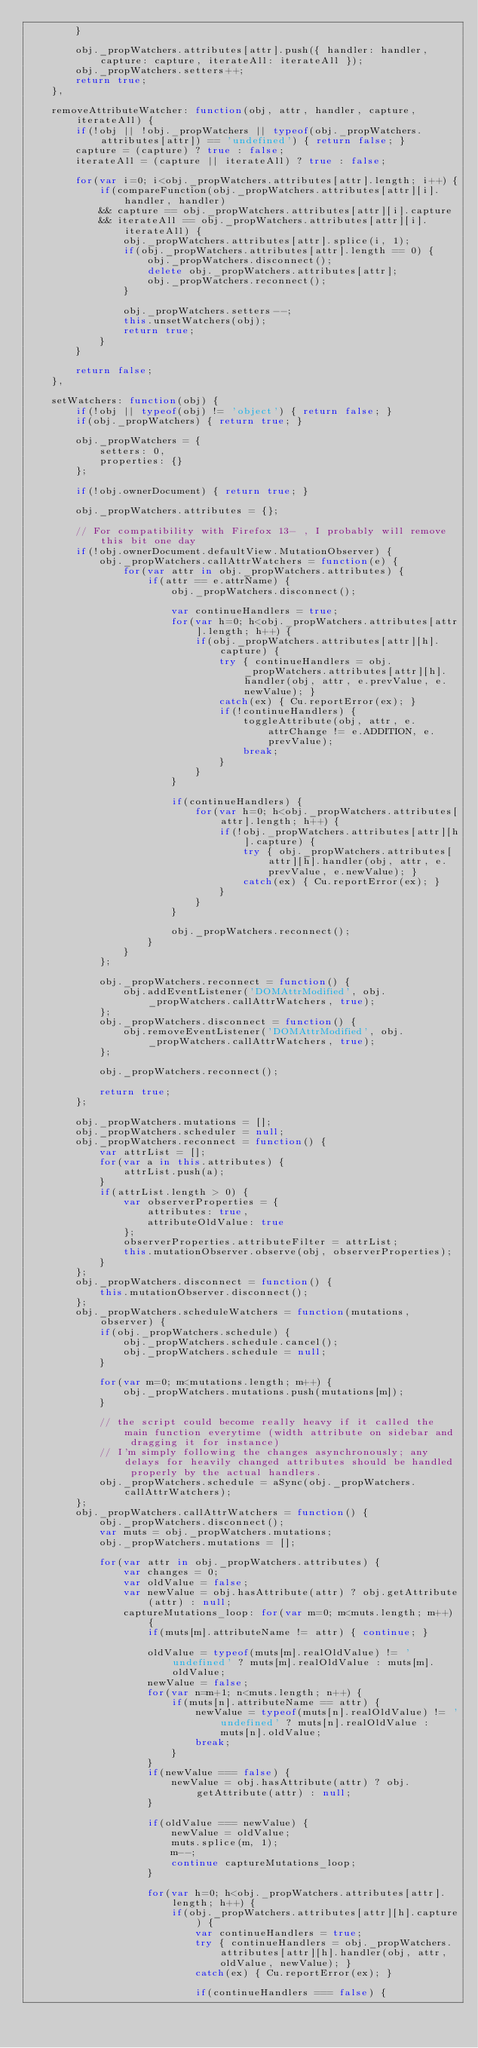<code> <loc_0><loc_0><loc_500><loc_500><_JavaScript_>		}
		
		obj._propWatchers.attributes[attr].push({ handler: handler, capture: capture, iterateAll: iterateAll });
		obj._propWatchers.setters++;
		return true;
	},
	
	removeAttributeWatcher: function(obj, attr, handler, capture, iterateAll) {
		if(!obj || !obj._propWatchers || typeof(obj._propWatchers.attributes[attr]) == 'undefined') { return false; }
		capture = (capture) ? true : false;
		iterateAll = (capture || iterateAll) ? true : false;
		
		for(var i=0; i<obj._propWatchers.attributes[attr].length; i++) {
			if(compareFunction(obj._propWatchers.attributes[attr][i].handler, handler)
			&& capture == obj._propWatchers.attributes[attr][i].capture
			&& iterateAll == obj._propWatchers.attributes[attr][i].iterateAll) {
				obj._propWatchers.attributes[attr].splice(i, 1);
				if(obj._propWatchers.attributes[attr].length == 0) {
					obj._propWatchers.disconnect();
					delete obj._propWatchers.attributes[attr];
					obj._propWatchers.reconnect();
				}
				
				obj._propWatchers.setters--;
				this.unsetWatchers(obj);
				return true;
			}
		}
		
		return false;
	},
	
	setWatchers: function(obj) {
		if(!obj || typeof(obj) != 'object') { return false; }
		if(obj._propWatchers) { return true; }
		
		obj._propWatchers = {
			setters: 0,
			properties: {}
		};
		
		if(!obj.ownerDocument) { return true; }
		
		obj._propWatchers.attributes = {};
		
		// For compatibility with Firefox 13- , I probably will remove this bit one day 
		if(!obj.ownerDocument.defaultView.MutationObserver) {
			obj._propWatchers.callAttrWatchers = function(e) {
				for(var attr in obj._propWatchers.attributes) {
					if(attr == e.attrName) {
						obj._propWatchers.disconnect();
						
						var continueHandlers = true;
						for(var h=0; h<obj._propWatchers.attributes[attr].length; h++) {
							if(obj._propWatchers.attributes[attr][h].capture) {
								try { continueHandlers = obj._propWatchers.attributes[attr][h].handler(obj, attr, e.prevValue, e.newValue); }
								catch(ex) { Cu.reportError(ex); }
								if(!continueHandlers) {
									toggleAttribute(obj, attr, e.attrChange != e.ADDITION, e.prevValue);
									break;
								}
							}
						}
						
						if(continueHandlers) {
							for(var h=0; h<obj._propWatchers.attributes[attr].length; h++) {
								if(!obj._propWatchers.attributes[attr][h].capture) {
									try { obj._propWatchers.attributes[attr][h].handler(obj, attr, e.prevValue, e.newValue); }
									catch(ex) { Cu.reportError(ex); }
								}
							}
						}
						
						obj._propWatchers.reconnect();
					}
				}
			};
			
			obj._propWatchers.reconnect = function() {
				obj.addEventListener('DOMAttrModified', obj._propWatchers.callAttrWatchers, true);
			};
			obj._propWatchers.disconnect = function() {
				obj.removeEventListener('DOMAttrModified', obj._propWatchers.callAttrWatchers, true);
			};
			
			obj._propWatchers.reconnect();
			
			return true;
		};
			
		obj._propWatchers.mutations = [];
		obj._propWatchers.scheduler = null;
		obj._propWatchers.reconnect = function() {
			var attrList = [];
			for(var a in this.attributes) {
				attrList.push(a);
			}
			if(attrList.length > 0) {
				var observerProperties = {
					attributes: true,
					attributeOldValue: true
				};
				observerProperties.attributeFilter = attrList;
				this.mutationObserver.observe(obj, observerProperties);
			}
		};
		obj._propWatchers.disconnect = function() {
			this.mutationObserver.disconnect();
		};
		obj._propWatchers.scheduleWatchers = function(mutations, observer) {
			if(obj._propWatchers.schedule) {
				obj._propWatchers.schedule.cancel();
				obj._propWatchers.schedule = null;
			}
			
			for(var m=0; m<mutations.length; m++) {
				obj._propWatchers.mutations.push(mutations[m]);
			}
			
			// the script could become really heavy if it called the main function everytime (width attribute on sidebar and dragging it for instance)
			// I'm simply following the changes asynchronously; any delays for heavily changed attributes should be handled properly by the actual handlers.
			obj._propWatchers.schedule = aSync(obj._propWatchers.callAttrWatchers);
		};
		obj._propWatchers.callAttrWatchers = function() {
			obj._propWatchers.disconnect();
			var muts = obj._propWatchers.mutations;
			obj._propWatchers.mutations = [];
			
			for(var attr in obj._propWatchers.attributes) {
				var changes = 0;
				var oldValue = false;
				var newValue = obj.hasAttribute(attr) ? obj.getAttribute(attr) : null;
				captureMutations_loop: for(var m=0; m<muts.length; m++) {
					if(muts[m].attributeName != attr) { continue; }
					
					oldValue = typeof(muts[m].realOldValue) != 'undefined' ? muts[m].realOldValue : muts[m].oldValue;
					newValue = false;
					for(var n=m+1; n<muts.length; n++) {
						if(muts[n].attributeName == attr) {
							newValue = typeof(muts[n].realOldValue) != 'undefined' ? muts[n].realOldValue : muts[n].oldValue;
							break;
						}
					}
					if(newValue === false) {
						newValue = obj.hasAttribute(attr) ? obj.getAttribute(attr) : null;
					}
					
					if(oldValue === newValue) {
						newValue = oldValue;
						muts.splice(m, 1);
						m--;
						continue captureMutations_loop;
					}
					
					for(var h=0; h<obj._propWatchers.attributes[attr].length; h++) {
						if(obj._propWatchers.attributes[attr][h].capture) {
							var continueHandlers = true;
							try { continueHandlers = obj._propWatchers.attributes[attr][h].handler(obj, attr, oldValue, newValue); }
							catch(ex) { Cu.reportError(ex); }
							
							if(continueHandlers === false) {</code> 